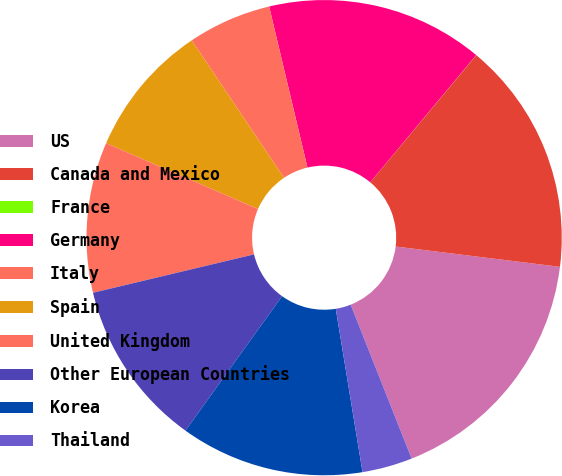Convert chart to OTSL. <chart><loc_0><loc_0><loc_500><loc_500><pie_chart><fcel>US<fcel>Canada and Mexico<fcel>France<fcel>Germany<fcel>Italy<fcel>Spain<fcel>United Kingdom<fcel>Other European Countries<fcel>Korea<fcel>Thailand<nl><fcel>17.04%<fcel>15.9%<fcel>0.01%<fcel>14.77%<fcel>5.69%<fcel>9.09%<fcel>10.23%<fcel>11.36%<fcel>12.5%<fcel>3.42%<nl></chart> 